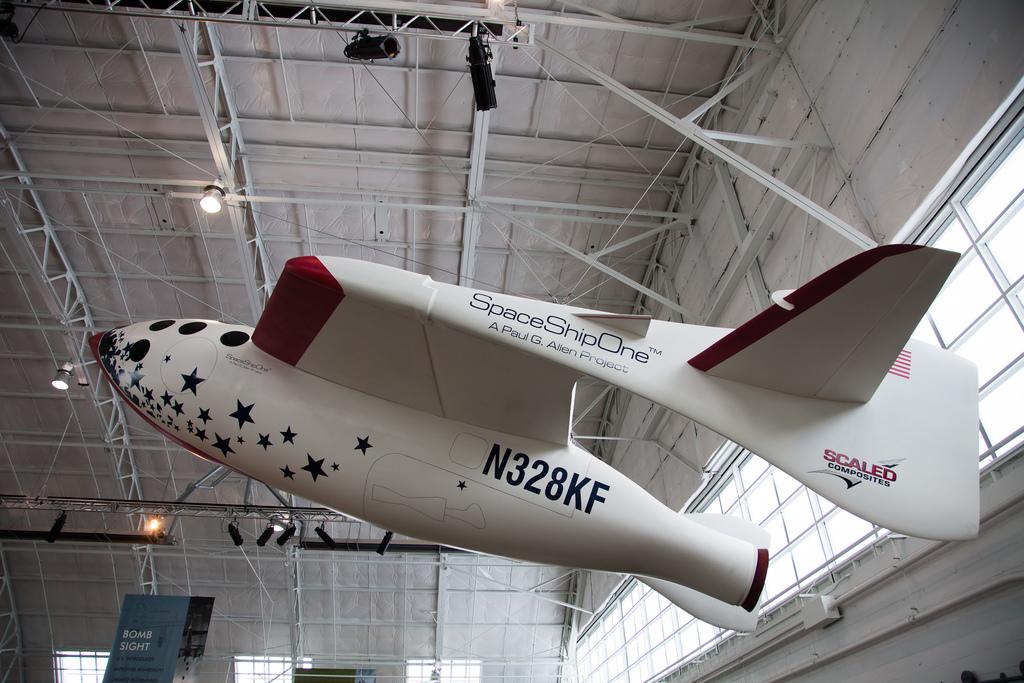What is the number and letter of the plane?
Provide a succinct answer. N328kf. Which company owns that aircraft?
Keep it short and to the point. Spaceshipone. 